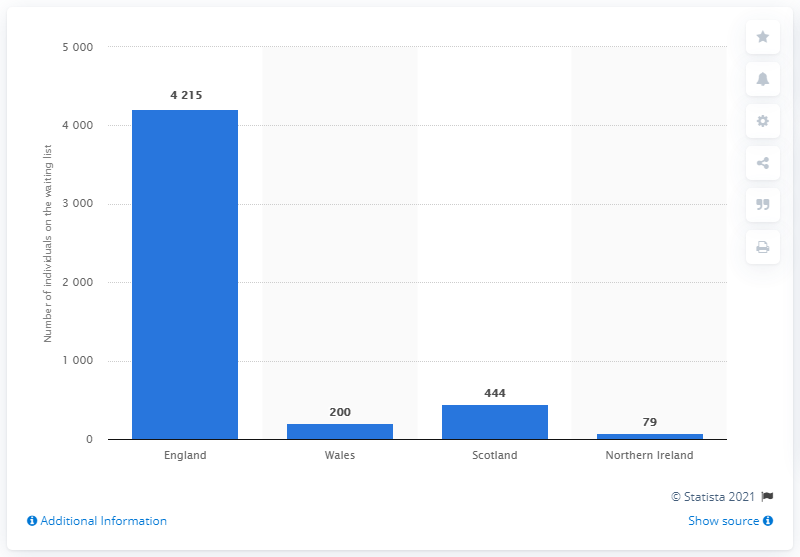Highlight a few significant elements in this photo. At the end of March 2020, there were 444 people on the lung transplant waiting list in Scotland. 